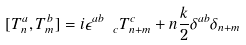<formula> <loc_0><loc_0><loc_500><loc_500>[ T ^ { a } _ { n } , T ^ { b } _ { m } ] = i \epsilon ^ { a b } _ { \ \ c } T ^ { c } _ { n + m } + n \frac { k } { 2 } \delta ^ { a b } \delta _ { n + m }</formula> 